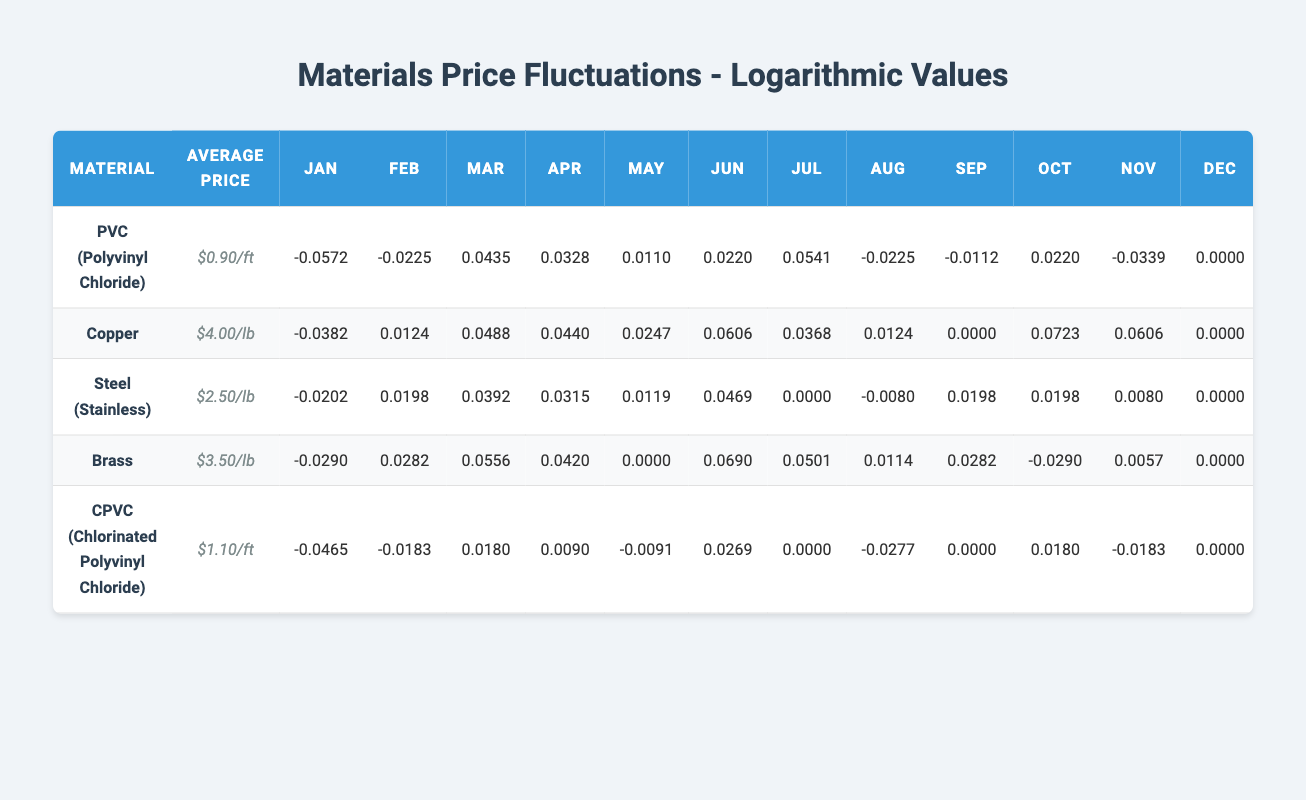What is the average price of Brass per pound? The table indicates that the average price per pound for Brass is $3.50.
Answer: $3.50 In which month did the price of Copper reach its highest point? By examining the price variation for Copper, we see that the highest price of $4.30 occurred in October.
Answer: October What is the price variation of Steel in March compared to its average price? The price in March for Steel is $2.60, and the average price is $2.50. The logarithmic value for this variation indicates an increase, confirming that it is higher than the average.
Answer: Higher What materials had a price lower than their average price in July? In July, PVC, Brass, and Steel all had prices lower than their respective average prices of $0.90/ft, $3.50/lb, and $2.50/lb. This shows that three materials had decreased prices relative to their averages.
Answer: PVC, Brass, Steel Calculate the overall price variation for CPVC from January to December. The price in January is $1.05 and in December is $1.10. The variation is calculated as (1.10 - 1.05) = 0.05. Comparing this to the average price of $1.10 indicates a small increase over the year.
Answer: $0.05 increase Were there any months where PVC had a price higher than its average price? Looking through the months, PVC prices were above the average of $0.90/ft in March ($0.94) and in July ($0.95), confirming that it increased above the average in these two months.
Answer: Yes What was the average price of Copper in the first half of the year? To find this, we calculate the average of Copper prices from January to June: (3.85 + 4.05 + 4.20 + 4.18 + 4.10 + 4.25) / 6 = 4.12. This shows a consistent price around 4.00 in the first half of the year, reflecting stability.
Answer: $4.12 Which material experienced the largest price drop in November as compared to October? By comparing the prices, Copper dropped from $4.30 in October to $4.25 in November, while Brass dropped from $3.40 to $3.52. The largest change occurred with Brass.
Answer: Brass How many materials had prices above their average in June? In June, only Steel ($2.62) and Copper ($4.25) had prices above their averages of $2.50 and $4 respectively, confirming that two materials saw increases in prices compared to their averages.
Answer: 2 